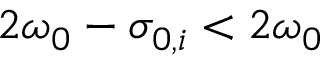Convert formula to latex. <formula><loc_0><loc_0><loc_500><loc_500>2 \omega _ { 0 } - \sigma _ { 0 , i } < 2 \omega _ { 0 }</formula> 